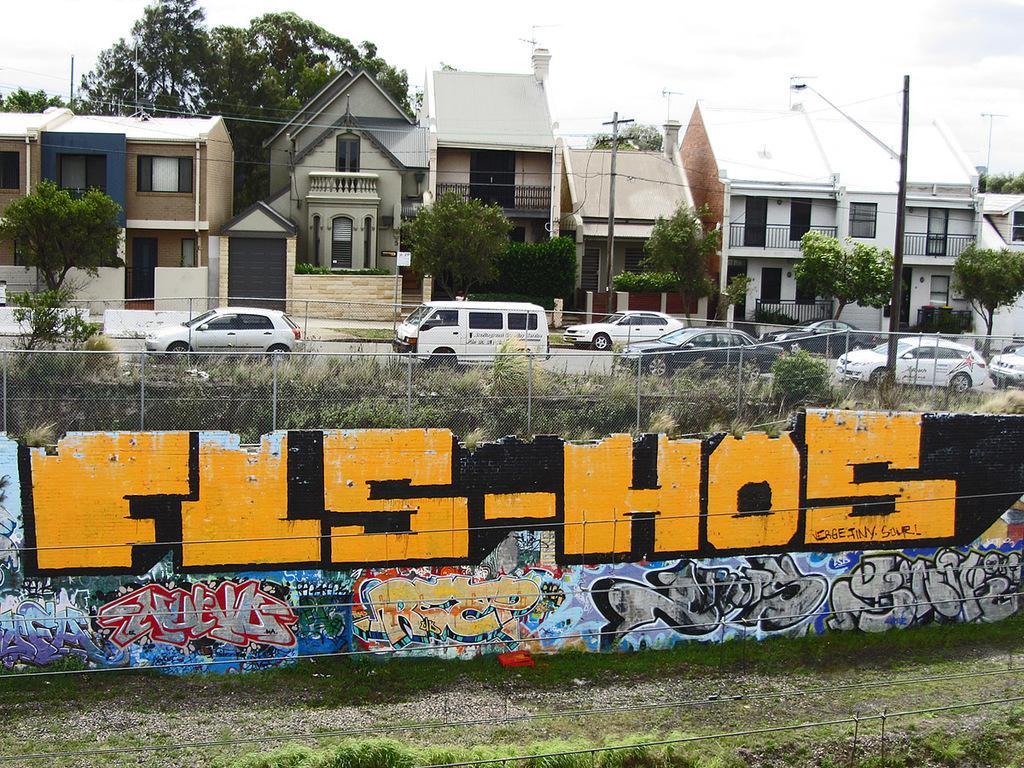How would you summarize this image in a sentence or two? In this image I can see vehicles on the road. Here I can see a wall which has painting on it and a fence. In the background I can see houses, poles, trees and the sky. Here I can see the grass. 